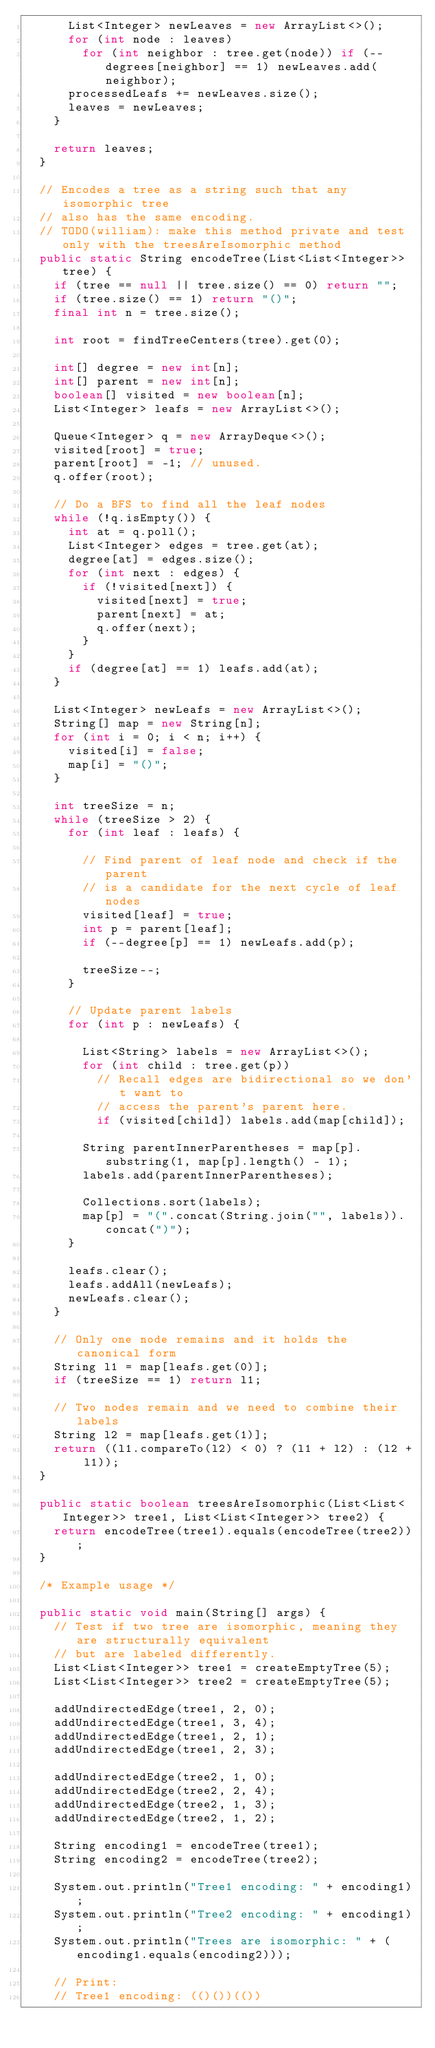Convert code to text. <code><loc_0><loc_0><loc_500><loc_500><_Java_>      List<Integer> newLeaves = new ArrayList<>();
      for (int node : leaves)
        for (int neighbor : tree.get(node)) if (--degrees[neighbor] == 1) newLeaves.add(neighbor);
      processedLeafs += newLeaves.size();
      leaves = newLeaves;
    }

    return leaves;
  }

  // Encodes a tree as a string such that any isomorphic tree
  // also has the same encoding.
  // TODO(william): make this method private and test only with the treesAreIsomorphic method
  public static String encodeTree(List<List<Integer>> tree) {
    if (tree == null || tree.size() == 0) return "";
    if (tree.size() == 1) return "()";
    final int n = tree.size();

    int root = findTreeCenters(tree).get(0);

    int[] degree = new int[n];
    int[] parent = new int[n];
    boolean[] visited = new boolean[n];
    List<Integer> leafs = new ArrayList<>();

    Queue<Integer> q = new ArrayDeque<>();
    visited[root] = true;
    parent[root] = -1; // unused.
    q.offer(root);

    // Do a BFS to find all the leaf nodes
    while (!q.isEmpty()) {
      int at = q.poll();
      List<Integer> edges = tree.get(at);
      degree[at] = edges.size();
      for (int next : edges) {
        if (!visited[next]) {
          visited[next] = true;
          parent[next] = at;
          q.offer(next);
        }
      }
      if (degree[at] == 1) leafs.add(at);
    }

    List<Integer> newLeafs = new ArrayList<>();
    String[] map = new String[n];
    for (int i = 0; i < n; i++) {
      visited[i] = false;
      map[i] = "()";
    }

    int treeSize = n;
    while (treeSize > 2) {
      for (int leaf : leafs) {

        // Find parent of leaf node and check if the parent
        // is a candidate for the next cycle of leaf nodes
        visited[leaf] = true;
        int p = parent[leaf];
        if (--degree[p] == 1) newLeafs.add(p);

        treeSize--;
      }

      // Update parent labels
      for (int p : newLeafs) {

        List<String> labels = new ArrayList<>();
        for (int child : tree.get(p))
          // Recall edges are bidirectional so we don't want to
          // access the parent's parent here.
          if (visited[child]) labels.add(map[child]);

        String parentInnerParentheses = map[p].substring(1, map[p].length() - 1);
        labels.add(parentInnerParentheses);

        Collections.sort(labels);
        map[p] = "(".concat(String.join("", labels)).concat(")");
      }

      leafs.clear();
      leafs.addAll(newLeafs);
      newLeafs.clear();
    }

    // Only one node remains and it holds the canonical form
    String l1 = map[leafs.get(0)];
    if (treeSize == 1) return l1;

    // Two nodes remain and we need to combine their labels
    String l2 = map[leafs.get(1)];
    return ((l1.compareTo(l2) < 0) ? (l1 + l2) : (l2 + l1));
  }

  public static boolean treesAreIsomorphic(List<List<Integer>> tree1, List<List<Integer>> tree2) {
    return encodeTree(tree1).equals(encodeTree(tree2));
  }

  /* Example usage */

  public static void main(String[] args) {
    // Test if two tree are isomorphic, meaning they are structurally equivalent
    // but are labeled differently.
    List<List<Integer>> tree1 = createEmptyTree(5);
    List<List<Integer>> tree2 = createEmptyTree(5);

    addUndirectedEdge(tree1, 2, 0);
    addUndirectedEdge(tree1, 3, 4);
    addUndirectedEdge(tree1, 2, 1);
    addUndirectedEdge(tree1, 2, 3);

    addUndirectedEdge(tree2, 1, 0);
    addUndirectedEdge(tree2, 2, 4);
    addUndirectedEdge(tree2, 1, 3);
    addUndirectedEdge(tree2, 1, 2);

    String encoding1 = encodeTree(tree1);
    String encoding2 = encodeTree(tree2);

    System.out.println("Tree1 encoding: " + encoding1);
    System.out.println("Tree2 encoding: " + encoding1);
    System.out.println("Trees are isomorphic: " + (encoding1.equals(encoding2)));

    // Print:
    // Tree1 encoding: (()())(())</code> 